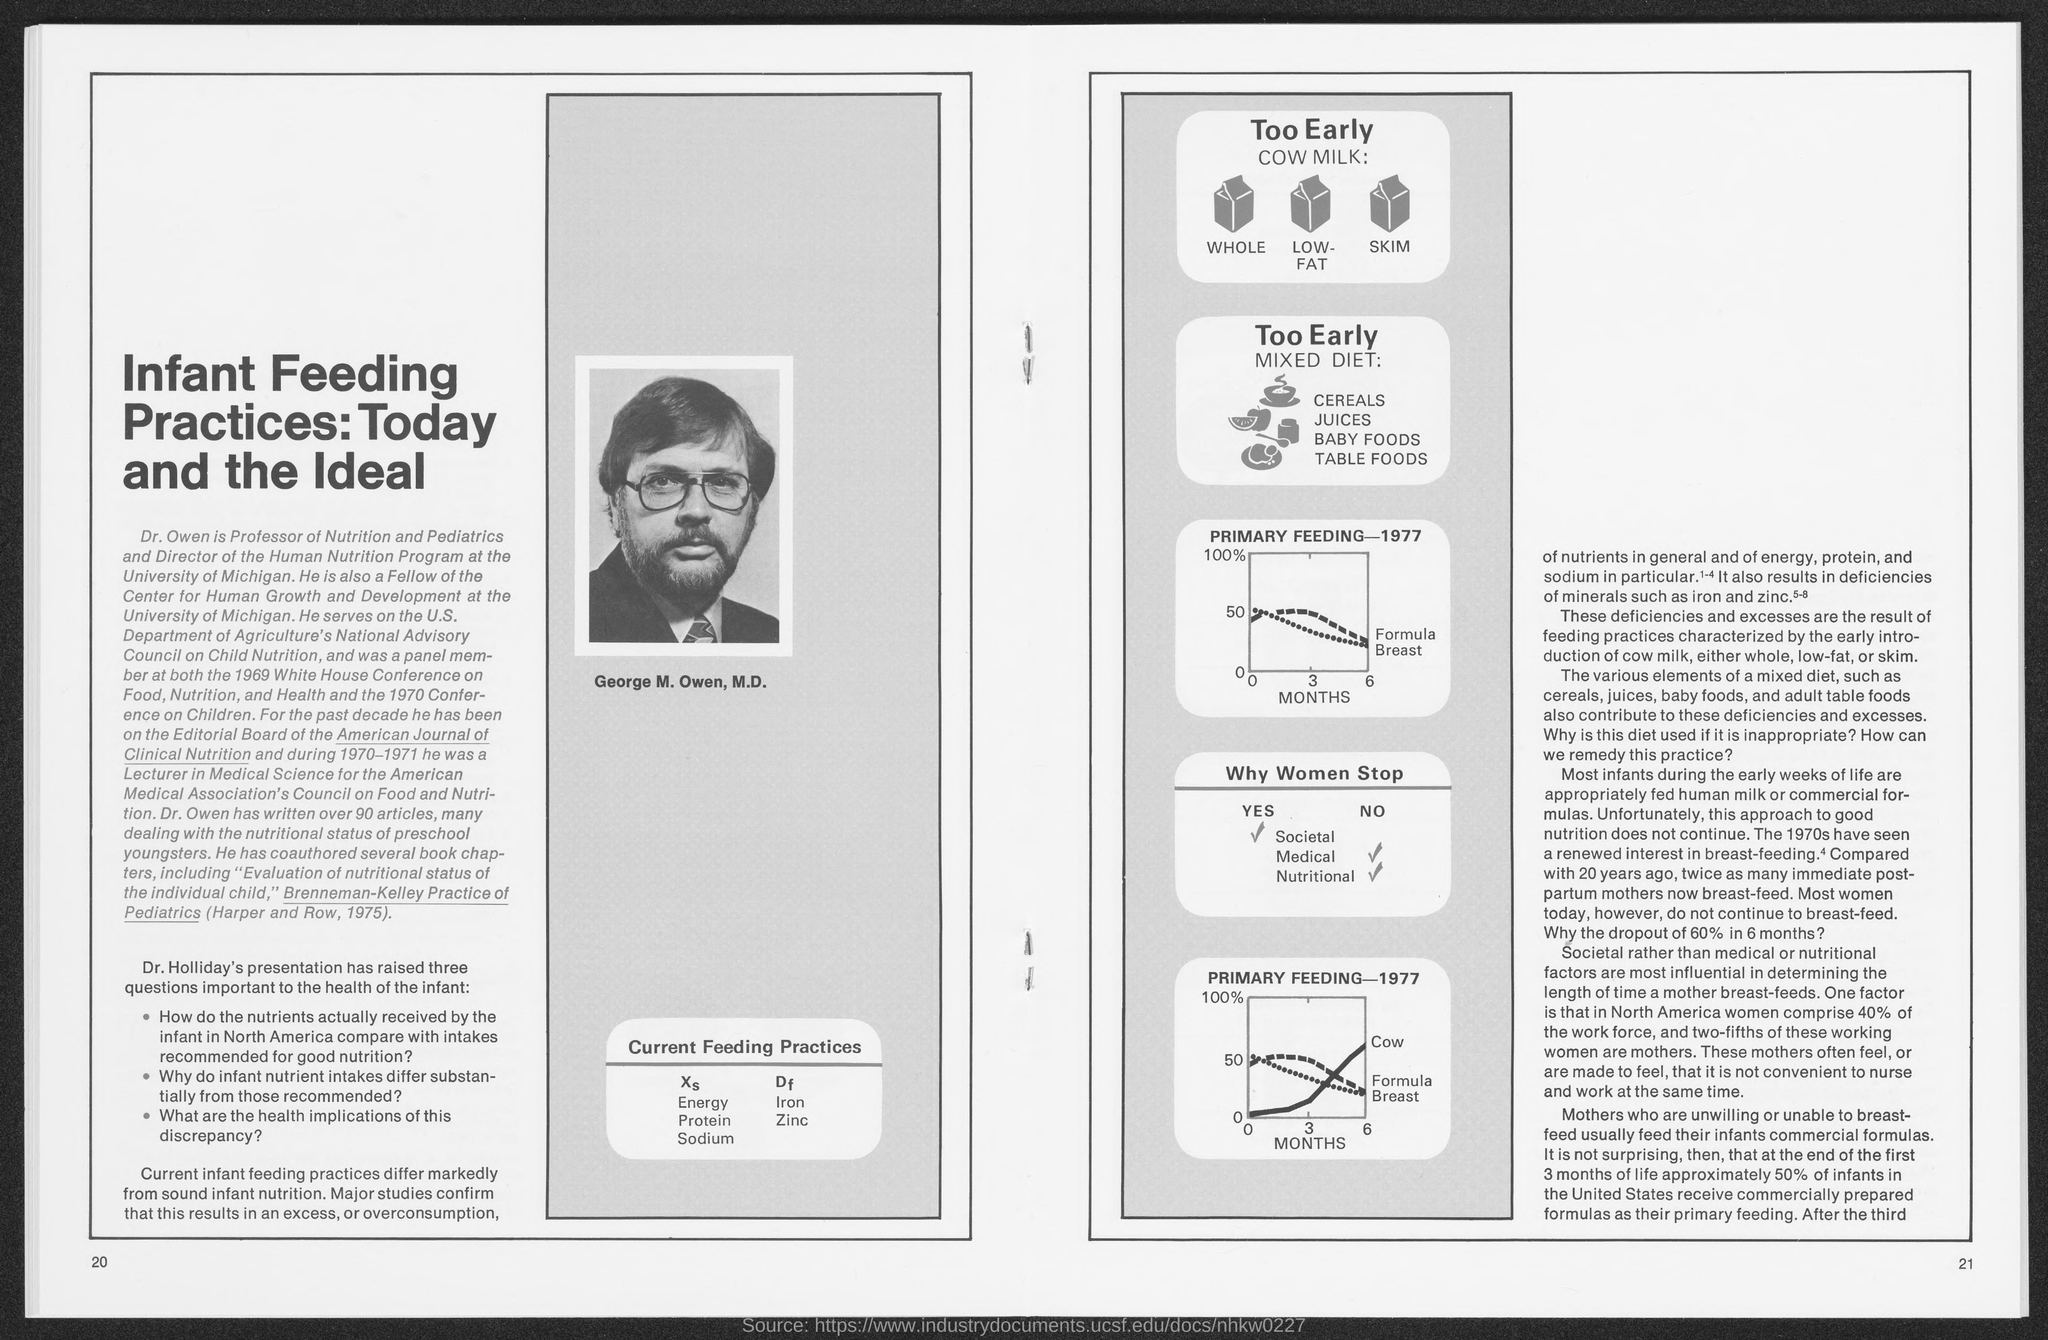Indicate a few pertinent items in this graphic. During the early weeks of life, infants are typically fed either human milk or commercial formulas. Over 90 articles have been written by Dr. Owen. The significant interest in breastfeeding was first shown in the year 1970. Dr. Owen played a key role as a Fellow at the Center for Human Growth and Development. Dr. Owen served as the Director of the Human Nutrition Program at the University of Michigan. 